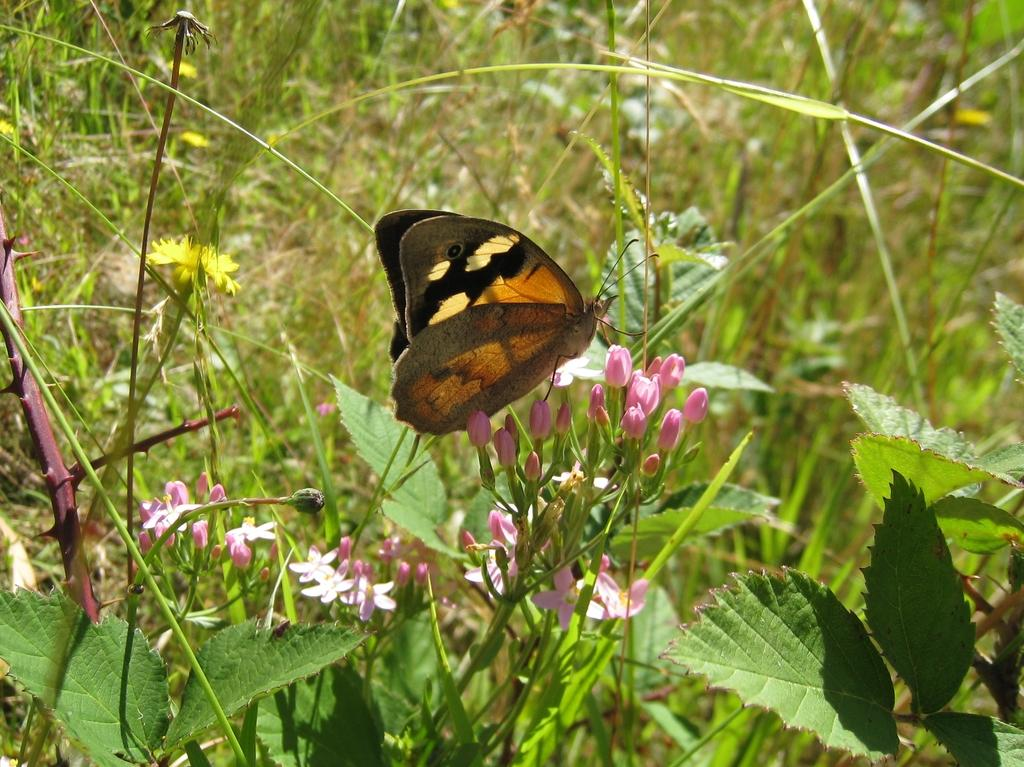What is the main subject in the center of the image? There is a butterfly in the center of the image. What type of vegetation can be seen in the image? Plants, grass, and flowers are visible in the image. What type of cart is being pulled by the snail in the image? There is no cart or snail present in the image; it features a butterfly and various plants. What is being served for lunch in the image? There is no reference to lunch or any food in the image. 